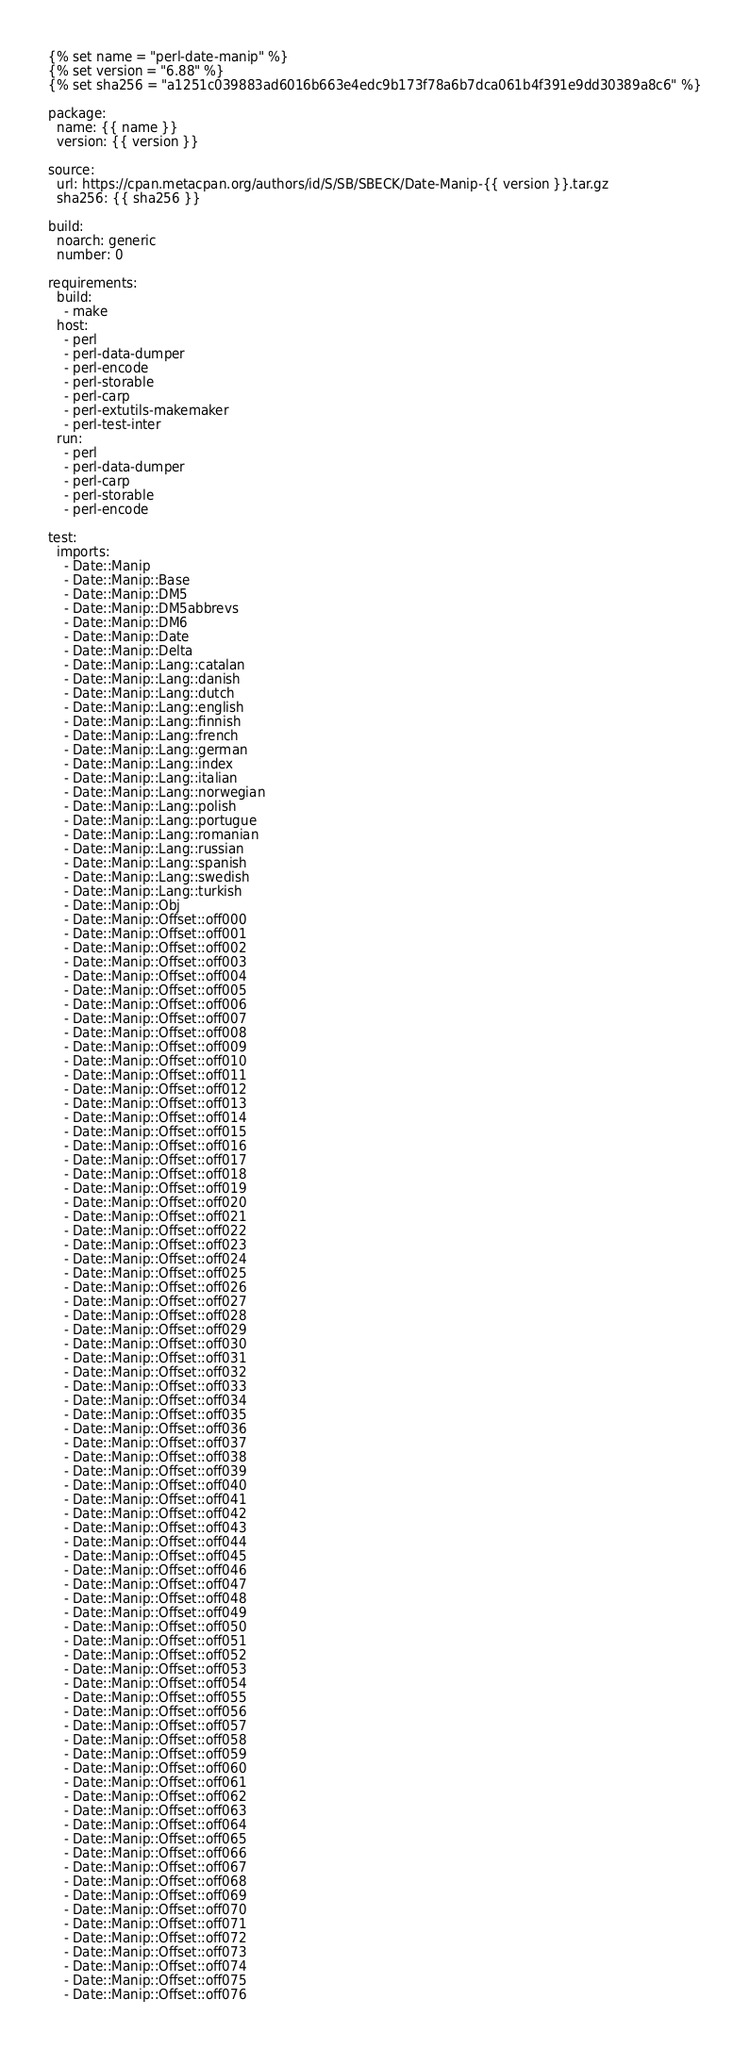Convert code to text. <code><loc_0><loc_0><loc_500><loc_500><_YAML_>{% set name = "perl-date-manip" %}
{% set version = "6.88" %}
{% set sha256 = "a1251c039883ad6016b663e4edc9b173f78a6b7dca061b4f391e9dd30389a8c6" %}

package:
  name: {{ name }}
  version: {{ version }}

source:
  url: https://cpan.metacpan.org/authors/id/S/SB/SBECK/Date-Manip-{{ version }}.tar.gz
  sha256: {{ sha256 }}

build:
  noarch: generic
  number: 0

requirements:
  build:
    - make
  host:
    - perl
    - perl-data-dumper
    - perl-encode
    - perl-storable
    - perl-carp
    - perl-extutils-makemaker
    - perl-test-inter
  run:
    - perl
    - perl-data-dumper
    - perl-carp
    - perl-storable
    - perl-encode

test:
  imports:
    - Date::Manip
    - Date::Manip::Base
    - Date::Manip::DM5
    - Date::Manip::DM5abbrevs
    - Date::Manip::DM6
    - Date::Manip::Date
    - Date::Manip::Delta
    - Date::Manip::Lang::catalan
    - Date::Manip::Lang::danish
    - Date::Manip::Lang::dutch
    - Date::Manip::Lang::english
    - Date::Manip::Lang::finnish
    - Date::Manip::Lang::french
    - Date::Manip::Lang::german
    - Date::Manip::Lang::index
    - Date::Manip::Lang::italian
    - Date::Manip::Lang::norwegian
    - Date::Manip::Lang::polish
    - Date::Manip::Lang::portugue
    - Date::Manip::Lang::romanian
    - Date::Manip::Lang::russian
    - Date::Manip::Lang::spanish
    - Date::Manip::Lang::swedish
    - Date::Manip::Lang::turkish
    - Date::Manip::Obj
    - Date::Manip::Offset::off000
    - Date::Manip::Offset::off001
    - Date::Manip::Offset::off002
    - Date::Manip::Offset::off003
    - Date::Manip::Offset::off004
    - Date::Manip::Offset::off005
    - Date::Manip::Offset::off006
    - Date::Manip::Offset::off007
    - Date::Manip::Offset::off008
    - Date::Manip::Offset::off009
    - Date::Manip::Offset::off010
    - Date::Manip::Offset::off011
    - Date::Manip::Offset::off012
    - Date::Manip::Offset::off013
    - Date::Manip::Offset::off014
    - Date::Manip::Offset::off015
    - Date::Manip::Offset::off016
    - Date::Manip::Offset::off017
    - Date::Manip::Offset::off018
    - Date::Manip::Offset::off019
    - Date::Manip::Offset::off020
    - Date::Manip::Offset::off021
    - Date::Manip::Offset::off022
    - Date::Manip::Offset::off023
    - Date::Manip::Offset::off024
    - Date::Manip::Offset::off025
    - Date::Manip::Offset::off026
    - Date::Manip::Offset::off027
    - Date::Manip::Offset::off028
    - Date::Manip::Offset::off029
    - Date::Manip::Offset::off030
    - Date::Manip::Offset::off031
    - Date::Manip::Offset::off032
    - Date::Manip::Offset::off033
    - Date::Manip::Offset::off034
    - Date::Manip::Offset::off035
    - Date::Manip::Offset::off036
    - Date::Manip::Offset::off037
    - Date::Manip::Offset::off038
    - Date::Manip::Offset::off039
    - Date::Manip::Offset::off040
    - Date::Manip::Offset::off041
    - Date::Manip::Offset::off042
    - Date::Manip::Offset::off043
    - Date::Manip::Offset::off044
    - Date::Manip::Offset::off045
    - Date::Manip::Offset::off046
    - Date::Manip::Offset::off047
    - Date::Manip::Offset::off048
    - Date::Manip::Offset::off049
    - Date::Manip::Offset::off050
    - Date::Manip::Offset::off051
    - Date::Manip::Offset::off052
    - Date::Manip::Offset::off053
    - Date::Manip::Offset::off054
    - Date::Manip::Offset::off055
    - Date::Manip::Offset::off056
    - Date::Manip::Offset::off057
    - Date::Manip::Offset::off058
    - Date::Manip::Offset::off059
    - Date::Manip::Offset::off060
    - Date::Manip::Offset::off061
    - Date::Manip::Offset::off062
    - Date::Manip::Offset::off063
    - Date::Manip::Offset::off064
    - Date::Manip::Offset::off065
    - Date::Manip::Offset::off066
    - Date::Manip::Offset::off067
    - Date::Manip::Offset::off068
    - Date::Manip::Offset::off069
    - Date::Manip::Offset::off070
    - Date::Manip::Offset::off071
    - Date::Manip::Offset::off072
    - Date::Manip::Offset::off073
    - Date::Manip::Offset::off074
    - Date::Manip::Offset::off075
    - Date::Manip::Offset::off076</code> 